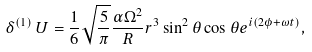<formula> <loc_0><loc_0><loc_500><loc_500>\delta ^ { ( 1 ) } \, U = \frac { 1 } { 6 } \sqrt { \frac { 5 } { \pi } } \frac { \alpha \Omega ^ { 2 } } { R } r ^ { 3 } \sin ^ { 2 } \theta \cos \theta e ^ { i ( 2 \phi + \omega t ) } ,</formula> 